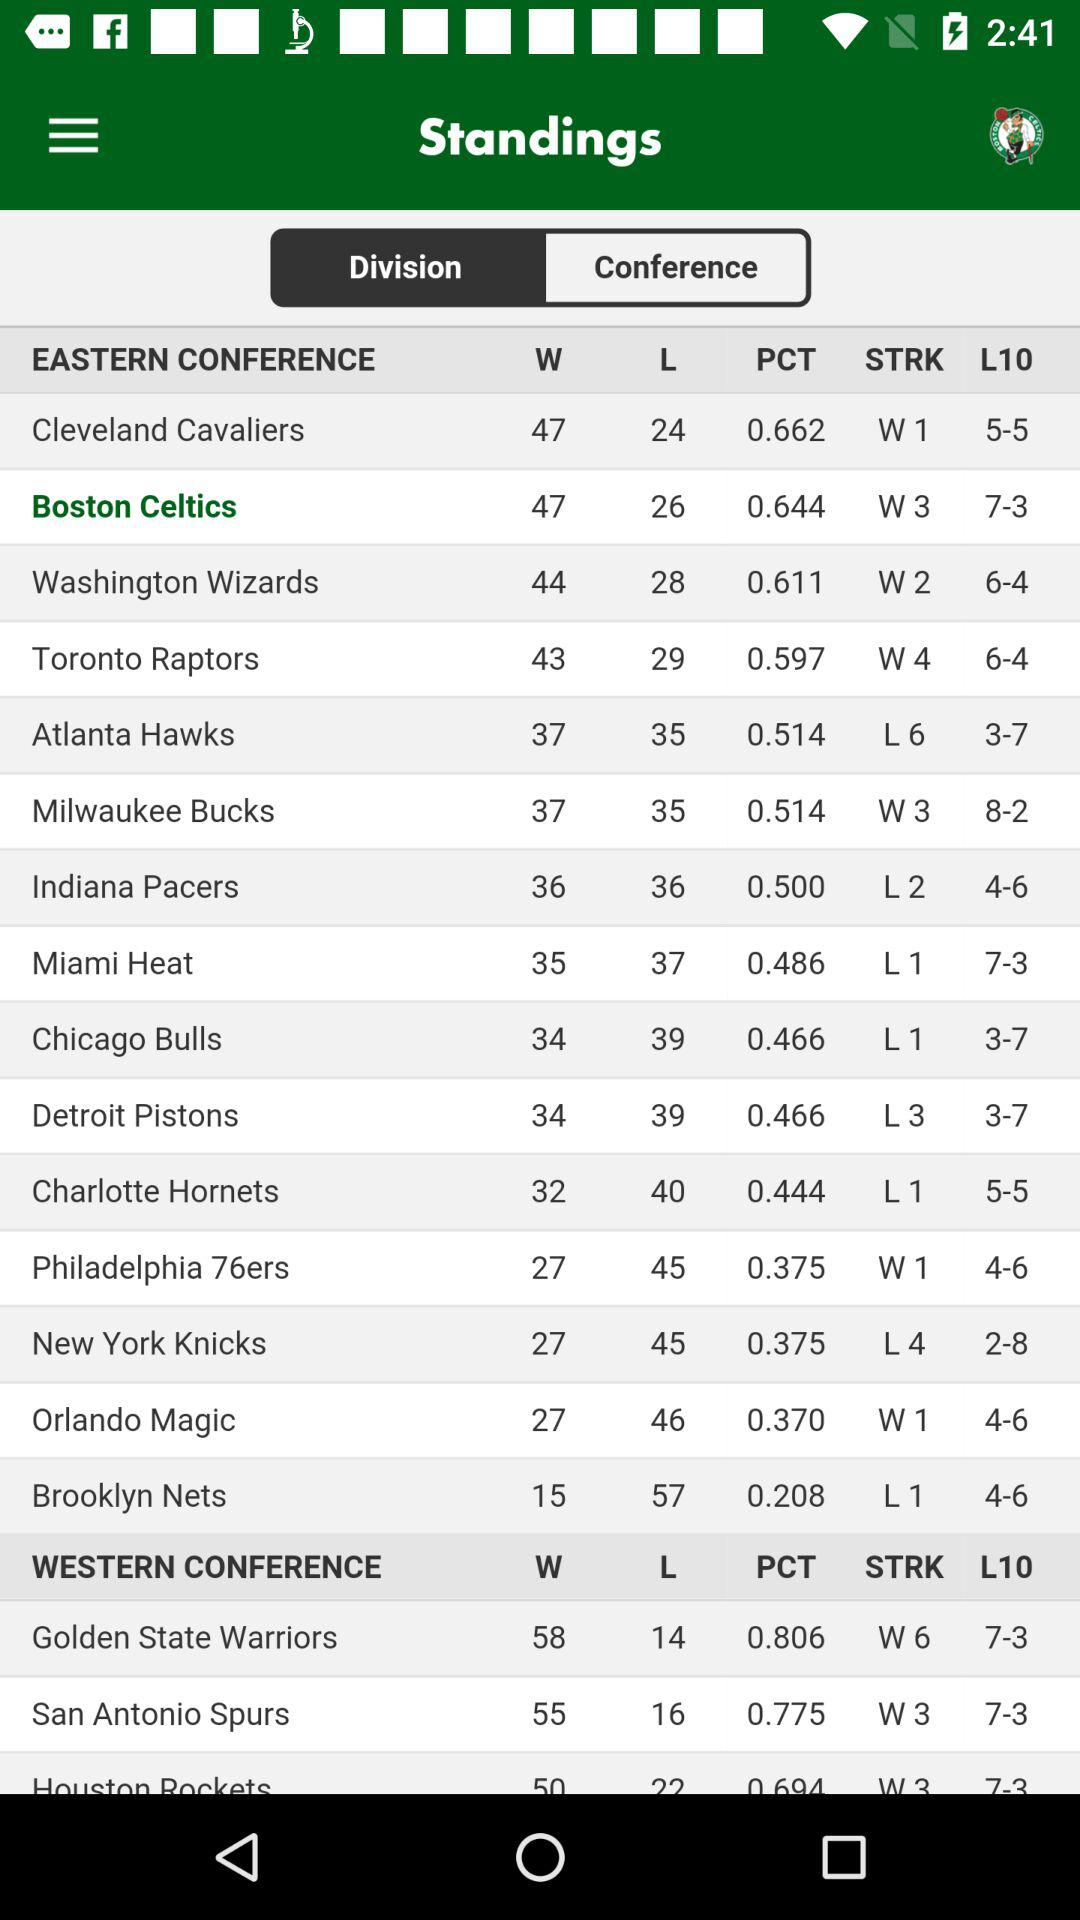Which tab is selected? The selected tab is "Conference". 